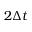Convert formula to latex. <formula><loc_0><loc_0><loc_500><loc_500>2 \Delta t</formula> 